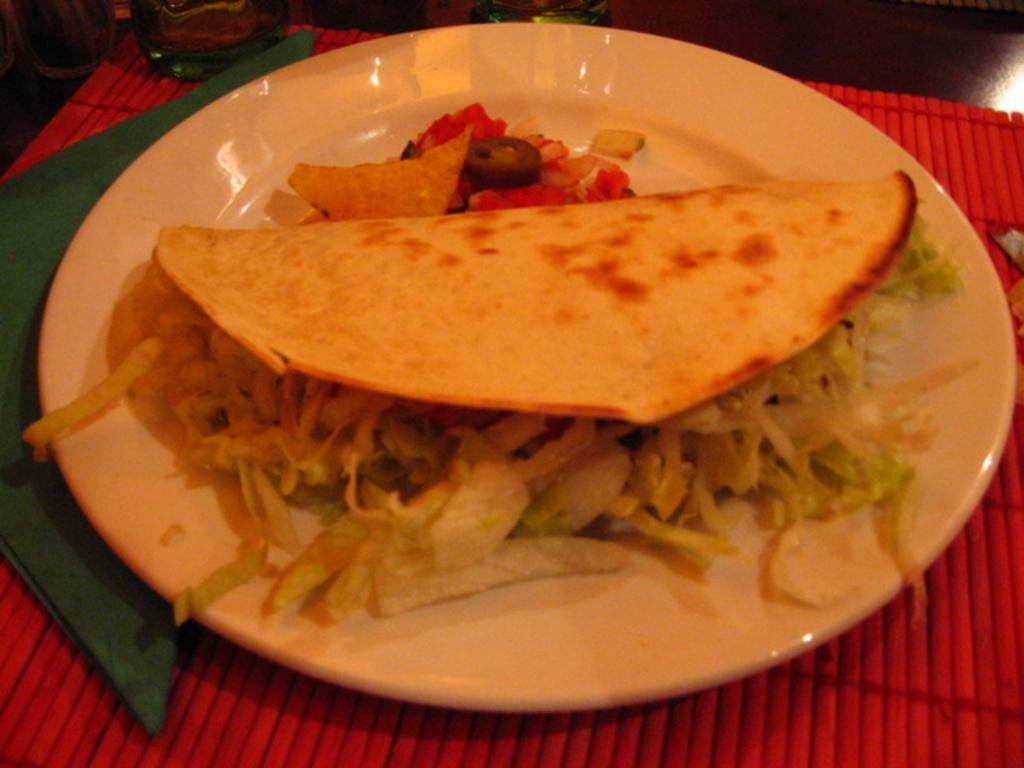What is on the plate that is visible in the image? There is food in a plate in the image. What type of material is the cloth made of in the image? The cloth in the image is not described in terms of material, but it is present. What other objects can be seen on the table in the image? There are other objects on the table in the image, but their specific details are not provided. What type of toys can be seen playing with the underwear in the image? There is no mention of toys or underwear in the image; it only features food on a plate and a cloth. 